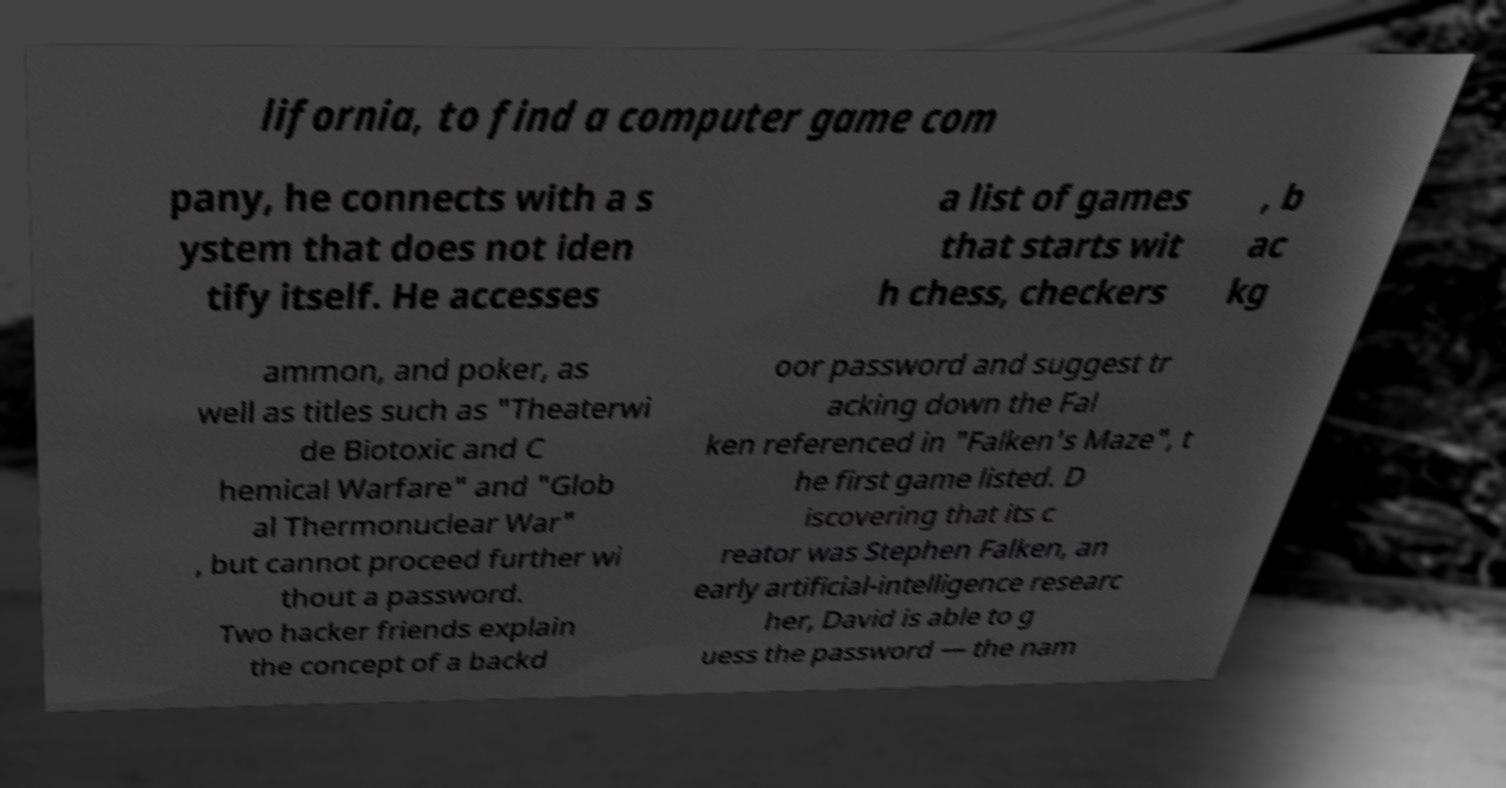Please identify and transcribe the text found in this image. lifornia, to find a computer game com pany, he connects with a s ystem that does not iden tify itself. He accesses a list of games that starts wit h chess, checkers , b ac kg ammon, and poker, as well as titles such as "Theaterwi de Biotoxic and C hemical Warfare" and "Glob al Thermonuclear War" , but cannot proceed further wi thout a password. Two hacker friends explain the concept of a backd oor password and suggest tr acking down the Fal ken referenced in "Falken's Maze", t he first game listed. D iscovering that its c reator was Stephen Falken, an early artificial-intelligence researc her, David is able to g uess the password — the nam 